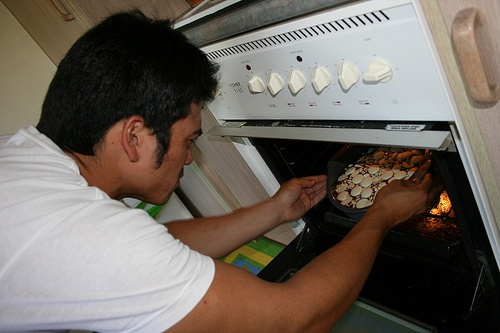Describe the objects in this image and their specific colors. I can see oven in black, darkgray, lightgray, and gray tones and people in black, lightgray, maroon, and darkgray tones in this image. 